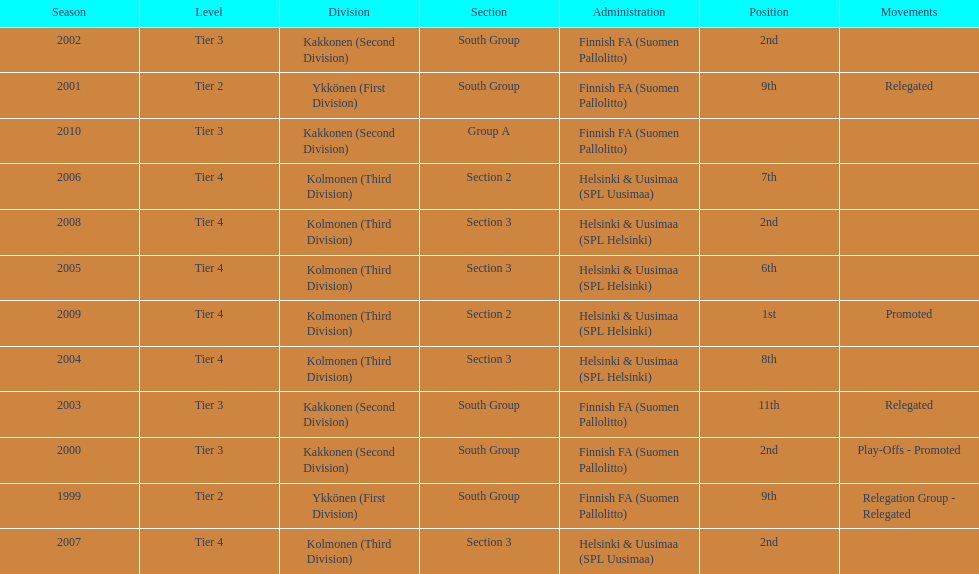How many times has this team been relegated? 3. 